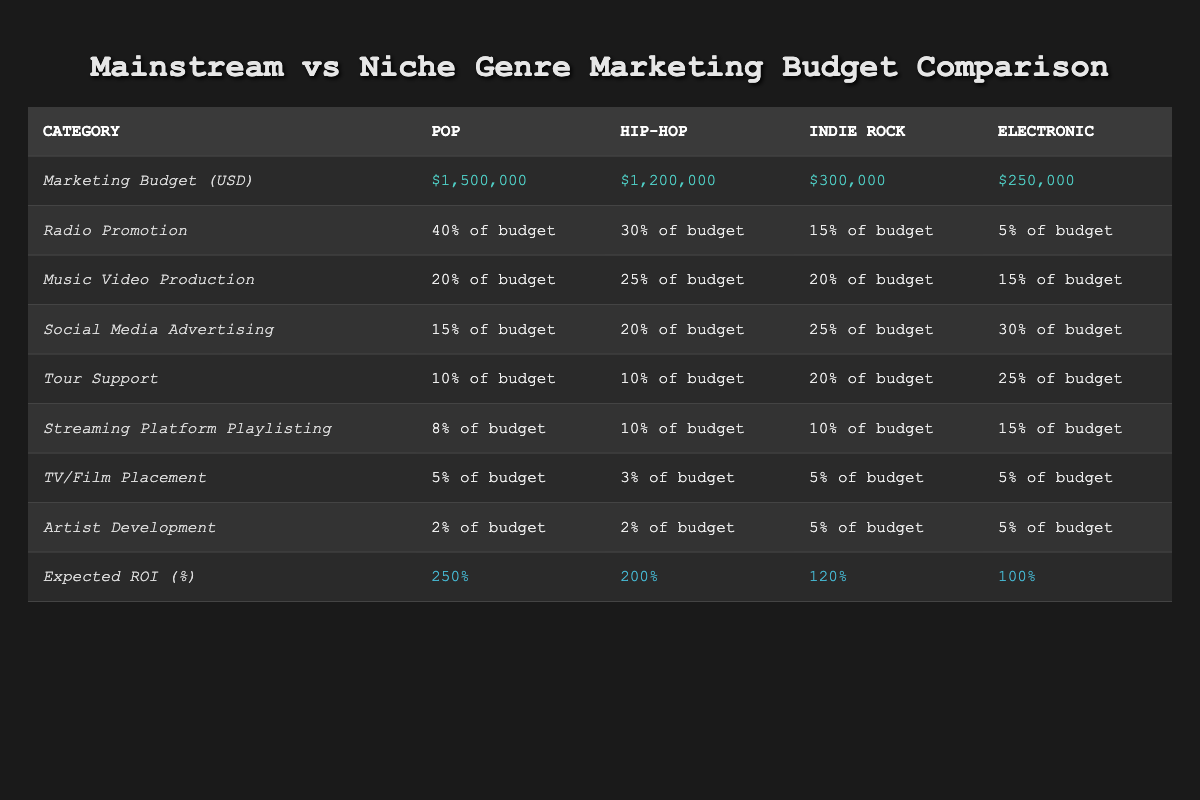What is the marketing budget for the Pop genre? The table shows the marketing budget for Pop listed under the "Marketing Budget (USD)" category. The value is $1,500,000.
Answer: $1,500,000 Which genre has the highest expected ROI? By inspecting the "Expected ROI (%)" row, Pop has the highest value at 250%, compared to Hip-Hop (200%), Indie Rock (120%), and Electronic (100%).
Answer: Pop What percentage of the budget is allocated to social media advertising for Electronic music? The table indicates that for Electronic, the "Social Media Advertising" percentage is 30% of the budget.
Answer: 30% of the budget If we combine the marketing budgets for Indie Rock and Electronic, what is the total? The marketing budget for Indie Rock is $300,000 and for Electronic it is $250,000. Adding these two gives $300,000 + $250,000 = $550,000.
Answer: $550,000 True or False: The total percentage of the budget allocated to radio promotion is larger for Hip-Hop than for Indie Rock. Hip-Hop allocates 30% of its budget to radio promotion while Indie Rock allocates 15%. Comparing these, Hip-Hop has a larger allocation.
Answer: True What percentage of the budget for the Pop genre is used for music video production? The music video production percentage for Pop is listed as 20% of the budget.
Answer: 20% of the budget Which genre has more budget allocated to tour support, Indie Rock or Electronic? Indie Rock has 20% of its budget for tour support, while Electronic has 25%. Comparing these values, Electronic has a larger allocation for tour support.
Answer: Electronic Calculating the average expected ROI for all genres listed: what is it? The expected ROI values are 250% for Pop, 200% for Hip-Hop, 120% for Indie Rock, and 100% for Electronic. Summing these gives 250 + 200 + 120 + 100 = 670. Then, dividing by 4 gives an average of 670 / 4 = 167.5
Answer: 167.5 How much less does Indie Rock's total marketing budget compare to Pop's? The marketing budget for Indie Rock is $300,000 and for Pop is $1,500,000. The difference is $1,500,000 - $300,000 = $1,200,000, indicating that Indie Rock has $1,200,000 less.
Answer: $1,200,000 